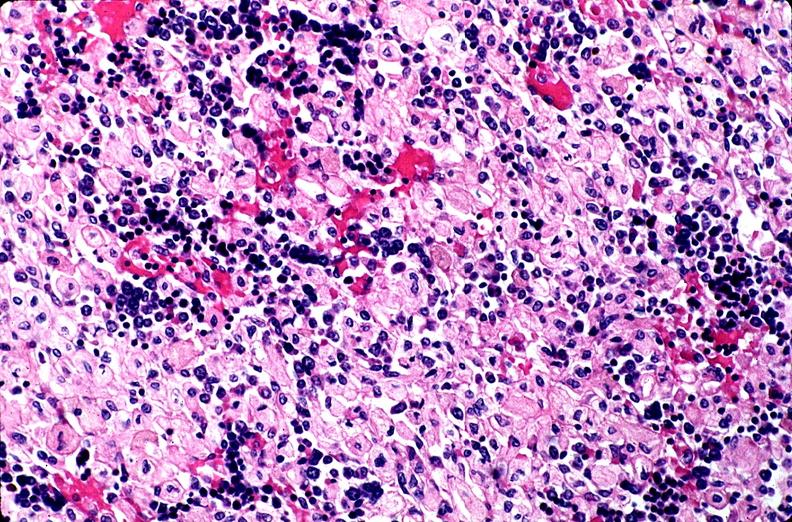s cervix duplication present?
Answer the question using a single word or phrase. No 